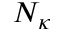<formula> <loc_0><loc_0><loc_500><loc_500>N _ { \kappa }</formula> 